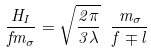<formula> <loc_0><loc_0><loc_500><loc_500>\frac { H _ { I } } { f m _ { \sigma } } = \sqrt { \frac { 2 \pi } { 3 \lambda } } \ \frac { m _ { \sigma } } { f \mp l }</formula> 